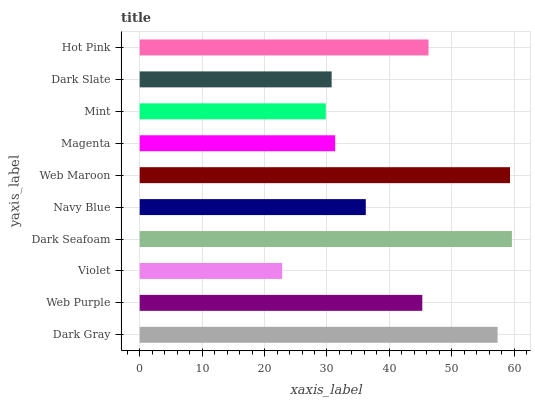Is Violet the minimum?
Answer yes or no. Yes. Is Dark Seafoam the maximum?
Answer yes or no. Yes. Is Web Purple the minimum?
Answer yes or no. No. Is Web Purple the maximum?
Answer yes or no. No. Is Dark Gray greater than Web Purple?
Answer yes or no. Yes. Is Web Purple less than Dark Gray?
Answer yes or no. Yes. Is Web Purple greater than Dark Gray?
Answer yes or no. No. Is Dark Gray less than Web Purple?
Answer yes or no. No. Is Web Purple the high median?
Answer yes or no. Yes. Is Navy Blue the low median?
Answer yes or no. Yes. Is Magenta the high median?
Answer yes or no. No. Is Dark Gray the low median?
Answer yes or no. No. 